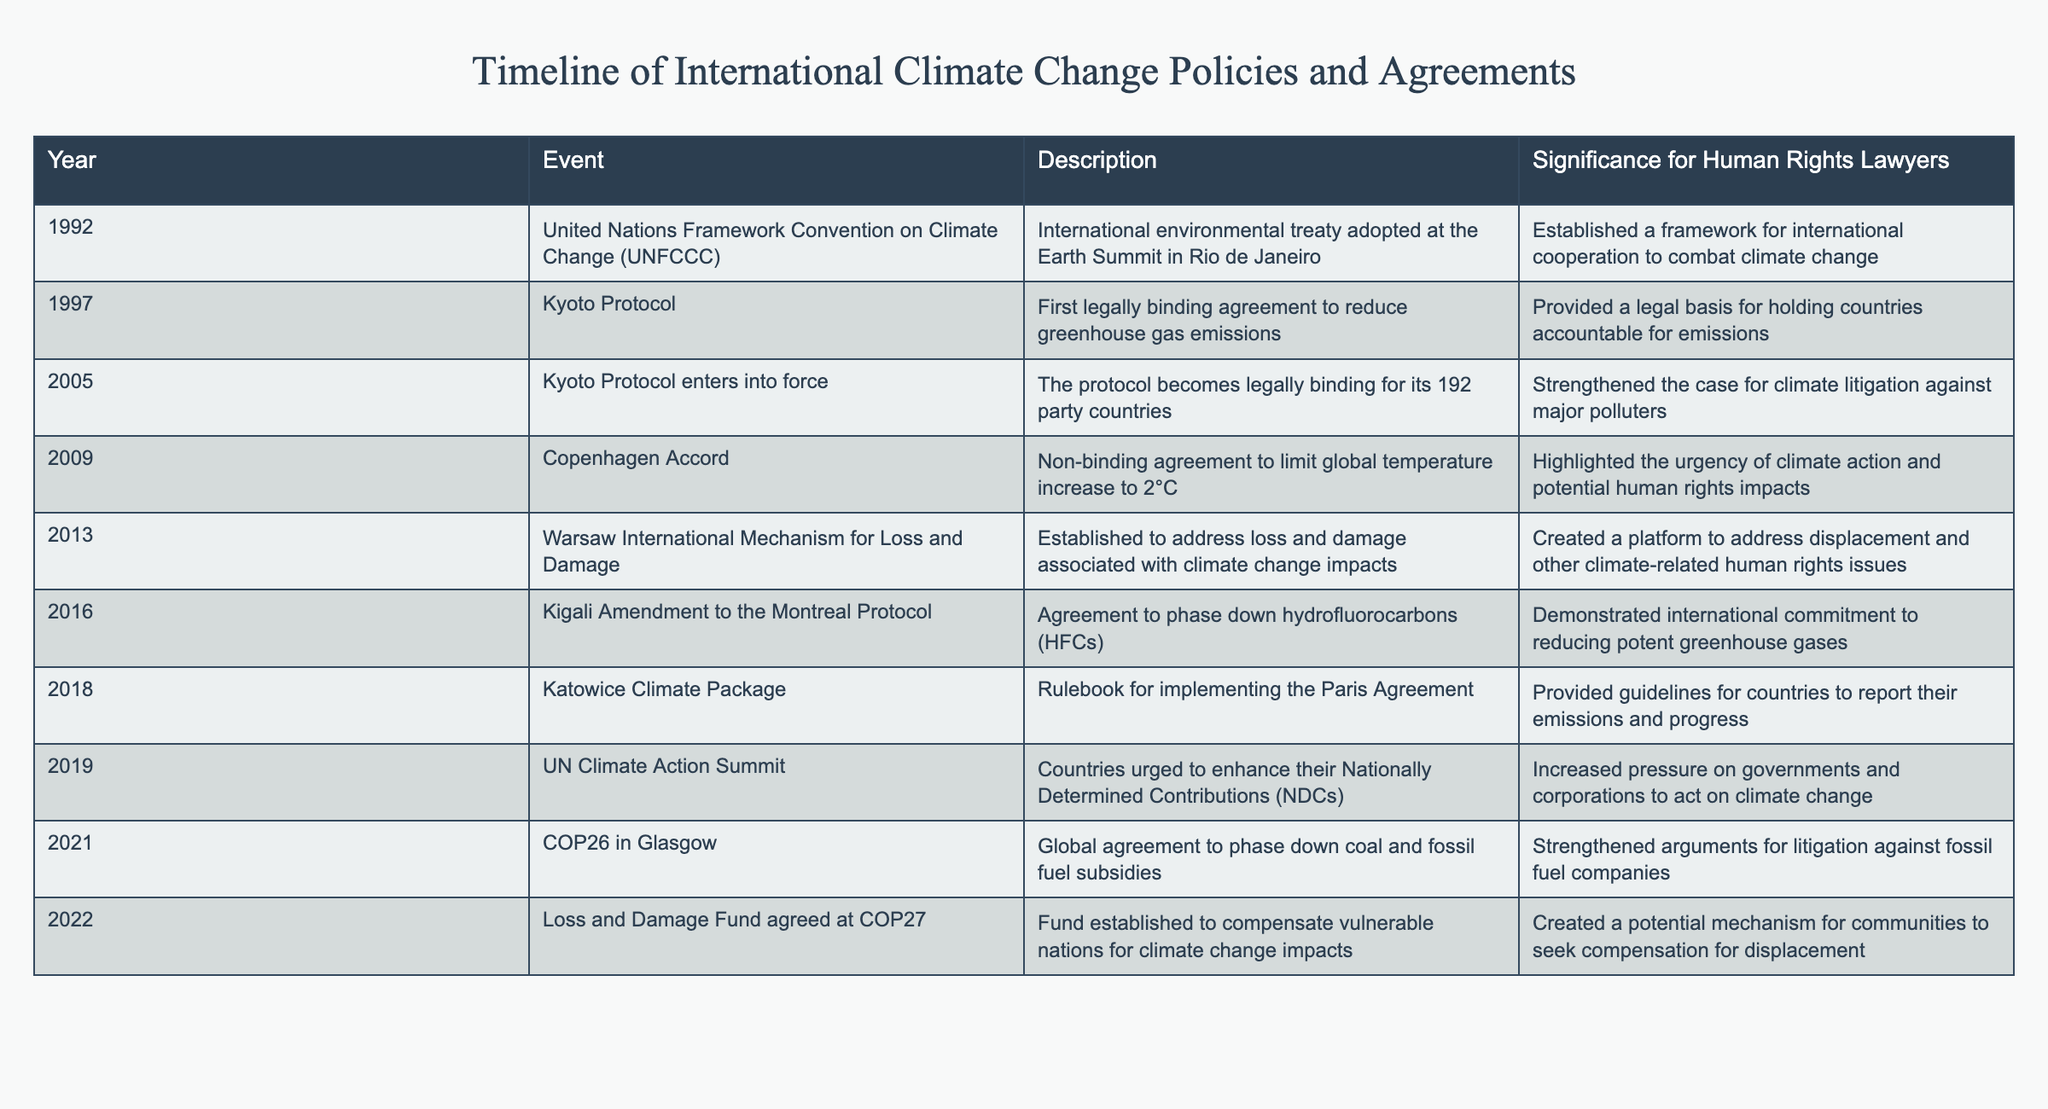What year was the United Nations Framework Convention on Climate Change adopted? The table indicates that the United Nations Framework Convention on Climate Change was adopted in the year 1992.
Answer: 1992 What is the significance of the Kyoto Protocol? The table describes the significance of the Kyoto Protocol as providing a legal basis for holding countries accountable for emissions, as it was the first legally binding agreement to reduce greenhouse gas emissions.
Answer: Legal accountability for emissions How many events mentioned in the table were established after 2000? Events after 2000 include the Warsaw International Mechanism for Loss and Damage (2013), the Kigali Amendment to the Montreal Protocol (2016), the Katowice Climate Package (2018), the UN Climate Action Summit (2019), and the COP26 in Glasgow (2021). This totals five events.
Answer: 5 Was the Copenhagen Accord a binding agreement? The table clearly states that the Copenhagen Accord was a non-binding agreement aimed at limiting global temperature increases to 2 degrees Celsius.
Answer: No Which event created a platform to address displacement related to climate impacts? According to the table, the Warsaw International Mechanism for Loss and Damage, established in 2013, created a platform to address displacement and other climate-related human rights issues.
Answer: Warsaw International Mechanism for Loss and Damage What is the significance of the Loss and Damage Fund agreed at COP27? The table highlights that this fund was established to compensate vulnerable nations for the impacts of climate change, creating a potential mechanism for communities to seek compensation for displacement.
Answer: Compensation for vulnerable nations What was the main goal of the COP26 agreement? The table states that the COP26 agreement aimed to phase down coal and fossil fuel subsidies, a significant step for climate action and litigation against fossil fuel companies.
Answer: Phase down coal and fossil fuel subsidies What was the average year given for the events listed in the table? The years from the events listed in the table are 1992, 1997, 2005, 2009, 2013, 2016, 2018, 2019, 2021, and 2022. The average is calculated as (1992 + 1997 + 2005 + 2009 + 2013 + 2016 + 2018 + 2019 + 2021 + 2022) / 10 = 2010.2. Therefore, the average year is 2010.2.
Answer: 2010.2 